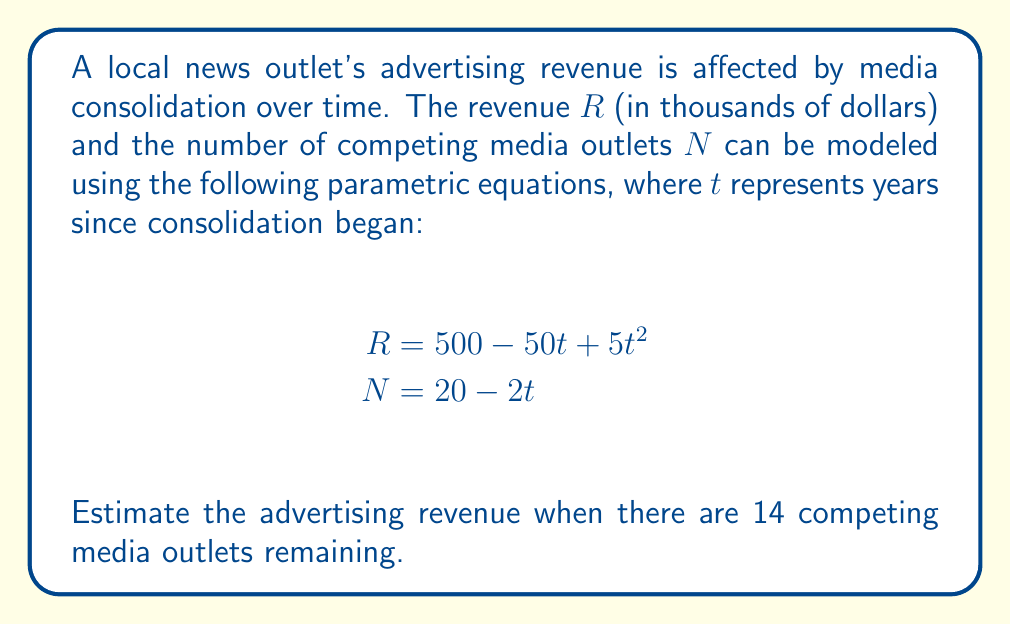Can you answer this question? To solve this problem, we need to follow these steps:

1) First, we need to find the value of $t$ when $N = 14$. We can use the equation for $N$:

   $$14 = 20 - 2t$$

2) Solve this equation for $t$:
   
   $$-6 = -2t$$
   $$t = 3$$

3) Now that we know $t = 3$, we can substitute this into the equation for $R$:

   $$R = 500 - 50t + 5t^2$$
   $$R = 500 - 50(3) + 5(3)^2$$

4) Let's calculate this step by step:

   $$R = 500 - 150 + 5(9)$$
   $$R = 500 - 150 + 45$$
   $$R = 350 + 45$$
   $$R = 395$$

5) Remember that $R$ is in thousands of dollars, so the final answer is $395,000.

This method demonstrates how parametric equations can be used to model complex relationships between variables in media consolidation scenarios.
Answer: $395,000 